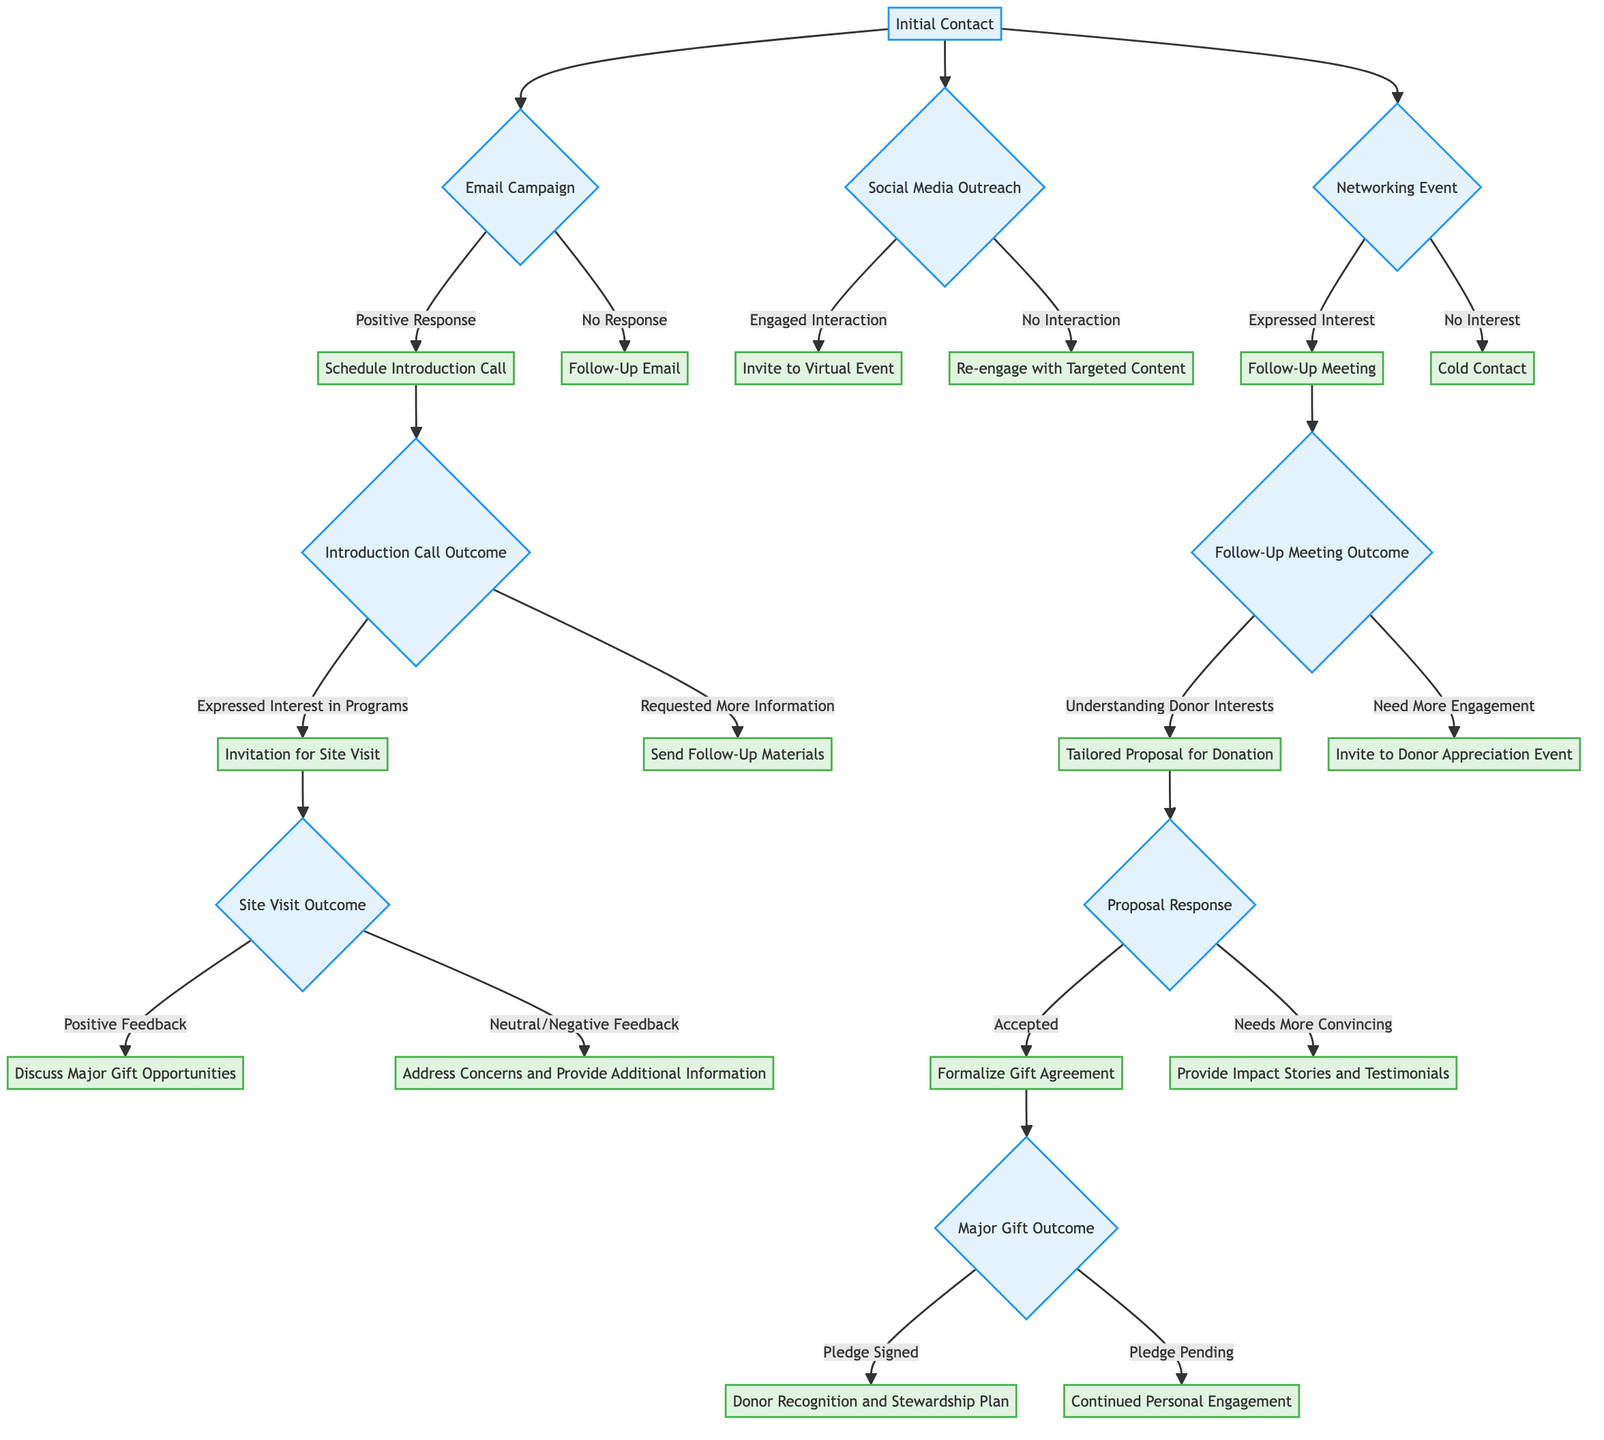What methods are used for initial contact? The diagram lists three methods for initial contact: Email Campaign, Social Media Outreach, and Networking Event. These methods are represented as the first set of options branching from the Initial Contact node.
Answer: Email Campaign, Social Media Outreach, Networking Event What follows a positive response to an email campaign? According to the diagram, if there is a positive response to an email campaign, the next step is to schedule an introduction call. This is indicated as the action taken after the positive response node stemming from the Email Campaign.
Answer: Schedule Introduction Call How many outcomes are there from an introduction call? The diagram indicates two potential outcomes from an introduction call: Expressed Interest in Programs and Requested More Information. These outcomes are the choices available after reaching the Introduction Call node.
Answer: 2 What happens after a follow-up meeting that needs more engagement? When a follow-up meeting leads to the need for more engagement, the next action is to invite the donor to a donor appreciation event, as shown in the flow after the Need More Engagement outcome.
Answer: Invite to Donor Appreciation Event What is the next step after a positive feedback from a site visit? A positive feedback from a site visit leads to discussing major gift opportunities. This is the action taken following the Positive Feedback outcome at the Site Visit node.
Answer: Discuss Major Gift Opportunities What do you need to provide if the donation proposal needs more convincing? If the proposal for donation needs more convincing, the next step is to provide impact stories and testimonials. This is specified directly in the diagram as the response to the Needs More Convincing node.
Answer: Provide Impact Stories and Testimonials What are the two major gift outcomes? The major gift outcomes identified in the diagram are Pledge Signed and Pledge Pending. These outcomes are the results stemming from the Major Gift node in the decision tree.
Answer: Pledge Signed, Pledge Pending What’s the action taken after a pledged signed? Following a pledge being signed, the next action is to implement a donor recognition and stewardship plan, as indicated in the flow from the Pledge Signed outcome.
Answer: Donor Recognition and Stewardship Plan 